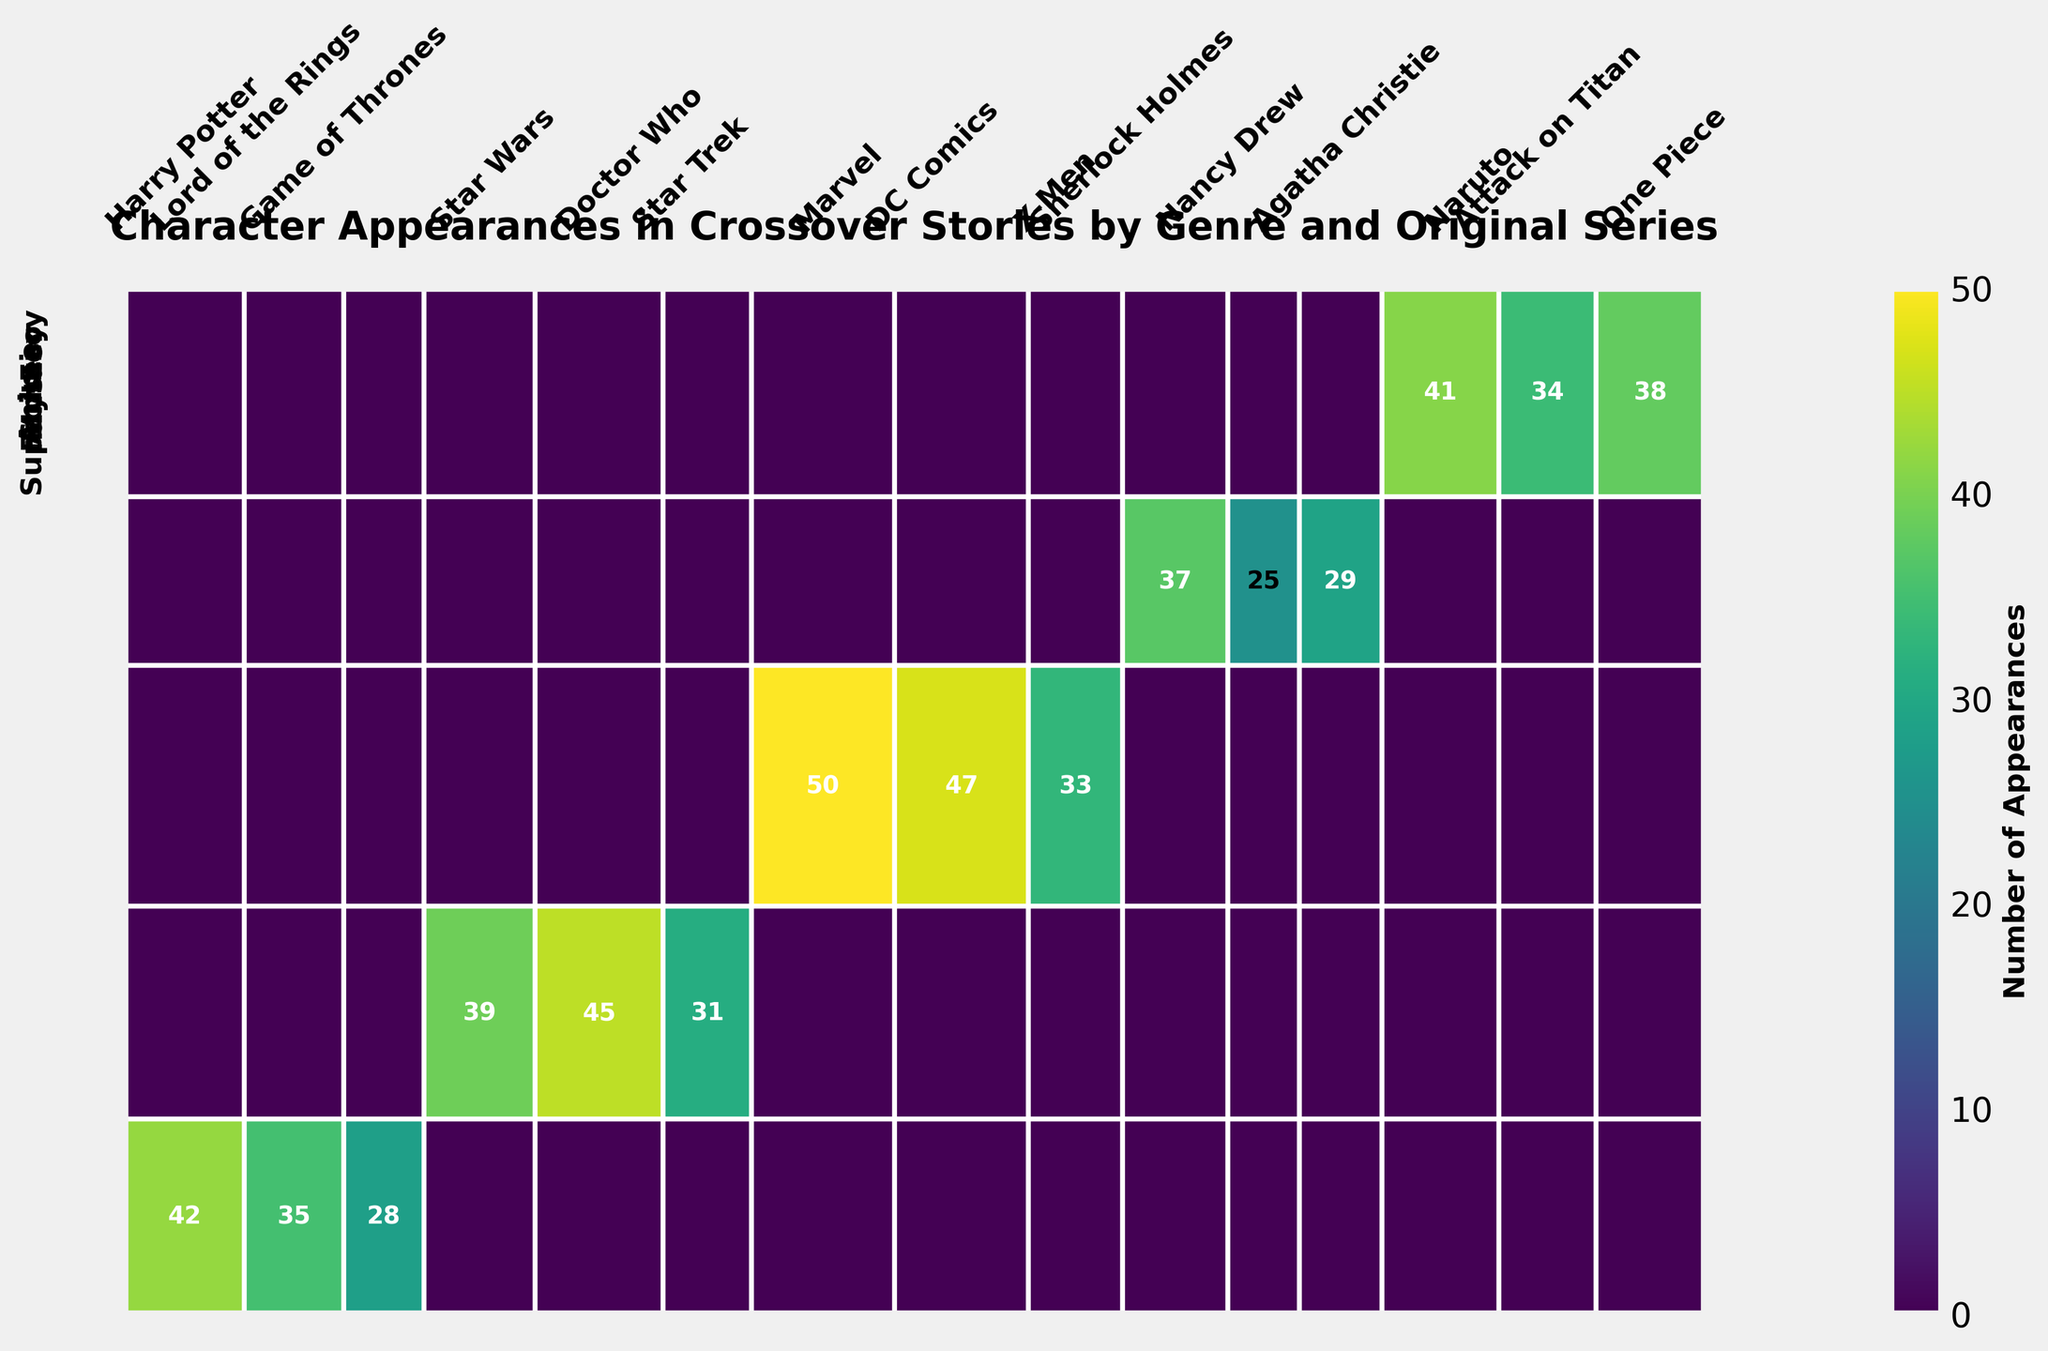What is the total number of appearances of characters from the Fantasy genre? Add the appearances of all characters in the Fantasy genre: Hermione Granger (42) + Legolas (35) + Daenerys Targaryen (28) = 105.
Answer: 105 Which character has the highest number of appearances? Based on the mosaic plot color intensity and annotations, Iron Man from Marvel (Superhero genre) has the highest number of appearances with 50.
Answer: Iron Man What is the average number of appearances for characters in the Mystery genre? Sum the appearances of all characters in the Mystery genre: Sherlock Holmes (37) + Nancy Drew (25) + Hercule Poirot (29) = 91. Then, divide by the number of characters (3): 91 / 3 ≈ 30.3.
Answer: 30.3 Are there more characters from the Sci-Fi genre or the Superhero genre? Count the total number of segments within the Sci-Fi genre and the Superhero genre in the plot. Sci-Fi has 3 segments (The Doctor, Luke Skywalker, Spock) and Superhero has 3 segments (Iron Man, Batman, Wolverine). Both genres have the same number of characters.
Answer: Same number Which genre has the smallest total number of appearances? Add the total appearances per genre and compare: Mystery (91), Sci-Fi (115), Superhero (130), Anime (113), Fantasy (105). The Mystery genre has the smallest number of appearances.
Answer: Mystery Which original series contributes the most to the Sci-Fi genre's total appearances? Check the segment sizes and annotations within the Sci-Fi genre. Doctor Who's "The Doctor" has the highest number of appearances with 45.
Answer: Doctor Who How many more appearances does Batman have compared to Daenerys Targaryen? Batman has 47 appearances (Superhero genre, DC Comics), and Daenerys Targaryen has 28 appearances (Fantasy genre, Game of Thrones). Subtract 28 from 47: 47 - 28 = 19.
Answer: 19 Which genre features the character with the fewest appearances, and who is that character? Compare the number of appearances of all characters. Nancy Drew (25 appearances, Mystery genre) has the fewest appearances.
Answer: Mystery, Nancy Drew Do characters from Anime appear more frequently than characters from Fantasy? Sum the total appearances in both genres: Anime (41 + 34 + 38 = 113), Fantasy (42 + 35 + 28 = 105). Anime characters appear more frequently than Fantasy characters.
Answer: Yes What color corresponds to the highest number of appearances, and which character does it represent? The darkest shade in the mosaic plot represents the highest number of appearances. This color corresponds to Iron Man from Marvel with 50 appearances.
Answer: Darkest shade, Iron Man 